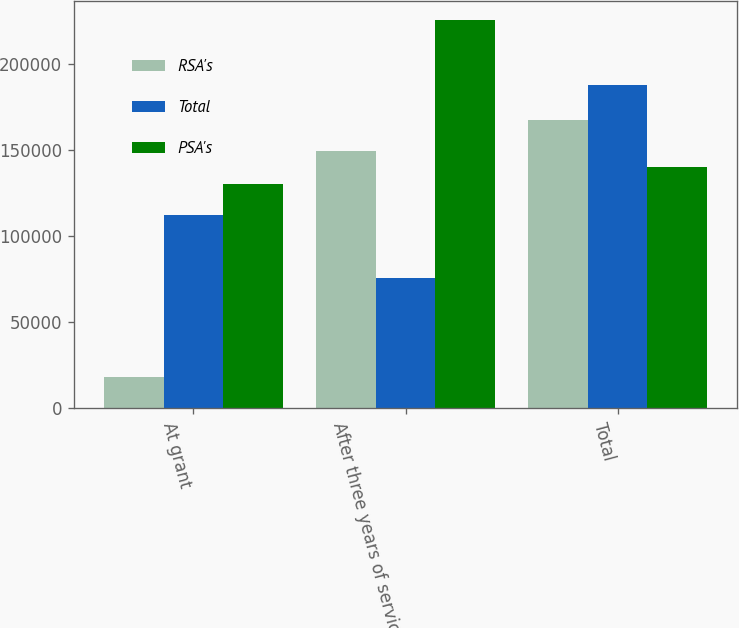<chart> <loc_0><loc_0><loc_500><loc_500><stacked_bar_chart><ecel><fcel>At grant<fcel>After three years of service<fcel>Total<nl><fcel>RSA's<fcel>18095<fcel>149420<fcel>167515<nl><fcel>Total<fcel>112028<fcel>75766<fcel>187794<nl><fcel>PSA's<fcel>130123<fcel>225186<fcel>139772<nl></chart> 